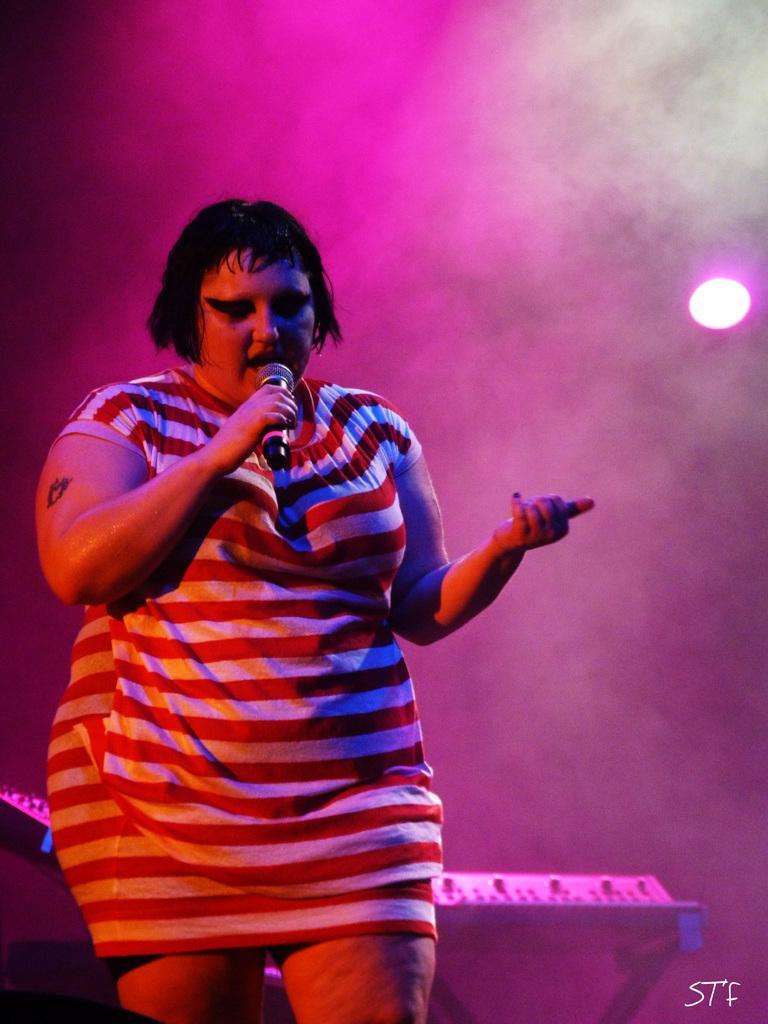Describe this image in one or two sentences. In this picture we can see a woman standing and holding a microphone, in the background there is a light, we can see smoke here, at the right bottom there is some text. 